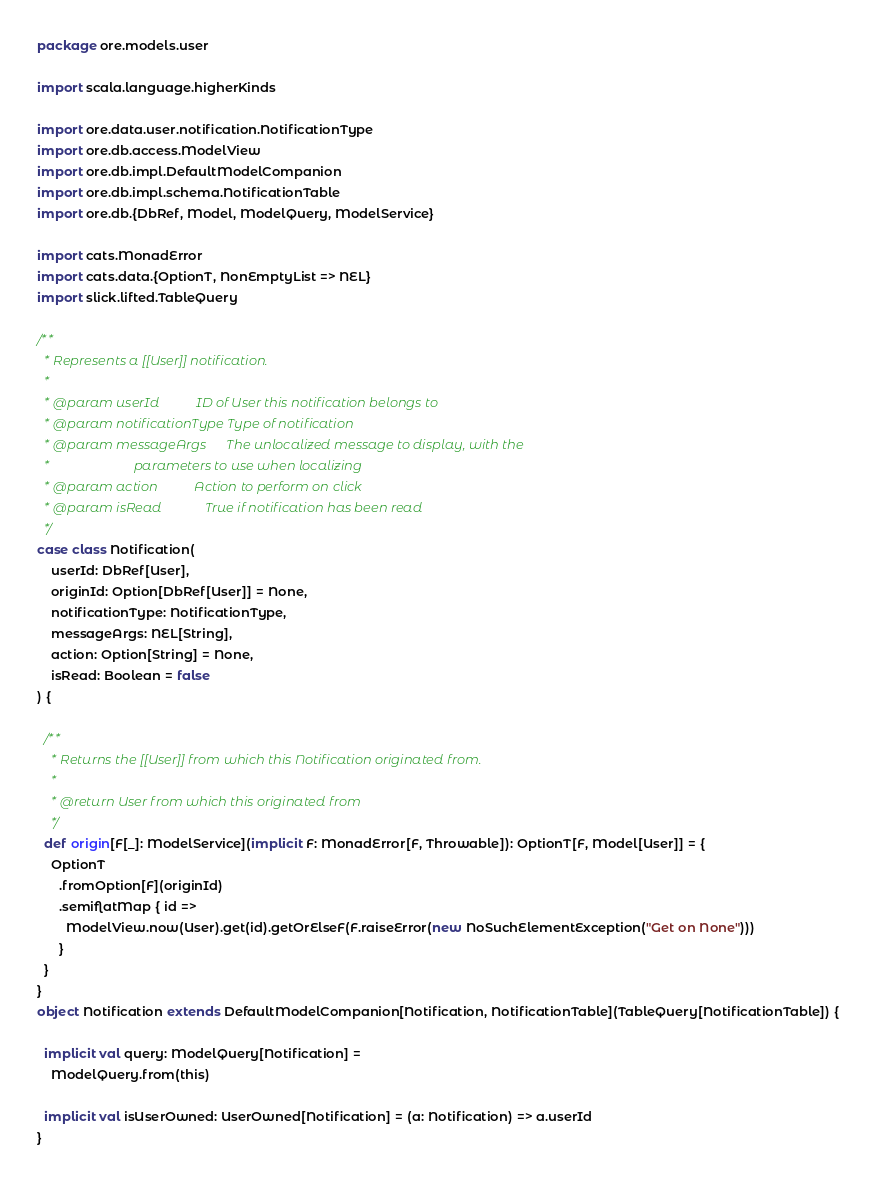Convert code to text. <code><loc_0><loc_0><loc_500><loc_500><_Scala_>package ore.models.user

import scala.language.higherKinds

import ore.data.user.notification.NotificationType
import ore.db.access.ModelView
import ore.db.impl.DefaultModelCompanion
import ore.db.impl.schema.NotificationTable
import ore.db.{DbRef, Model, ModelQuery, ModelService}

import cats.MonadError
import cats.data.{OptionT, NonEmptyList => NEL}
import slick.lifted.TableQuery

/**
  * Represents a [[User]] notification.
  *
  * @param userId           ID of User this notification belongs to
  * @param notificationType Type of notification
  * @param messageArgs      The unlocalized message to display, with the
  *                         parameters to use when localizing
  * @param action           Action to perform on click
  * @param isRead             True if notification has been read
  */
case class Notification(
    userId: DbRef[User],
    originId: Option[DbRef[User]] = None,
    notificationType: NotificationType,
    messageArgs: NEL[String],
    action: Option[String] = None,
    isRead: Boolean = false
) {

  /**
    * Returns the [[User]] from which this Notification originated from.
    *
    * @return User from which this originated from
    */
  def origin[F[_]: ModelService](implicit F: MonadError[F, Throwable]): OptionT[F, Model[User]] = {
    OptionT
      .fromOption[F](originId)
      .semiflatMap { id =>
        ModelView.now(User).get(id).getOrElseF(F.raiseError(new NoSuchElementException("Get on None")))
      }
  }
}
object Notification extends DefaultModelCompanion[Notification, NotificationTable](TableQuery[NotificationTable]) {

  implicit val query: ModelQuery[Notification] =
    ModelQuery.from(this)

  implicit val isUserOwned: UserOwned[Notification] = (a: Notification) => a.userId
}
</code> 